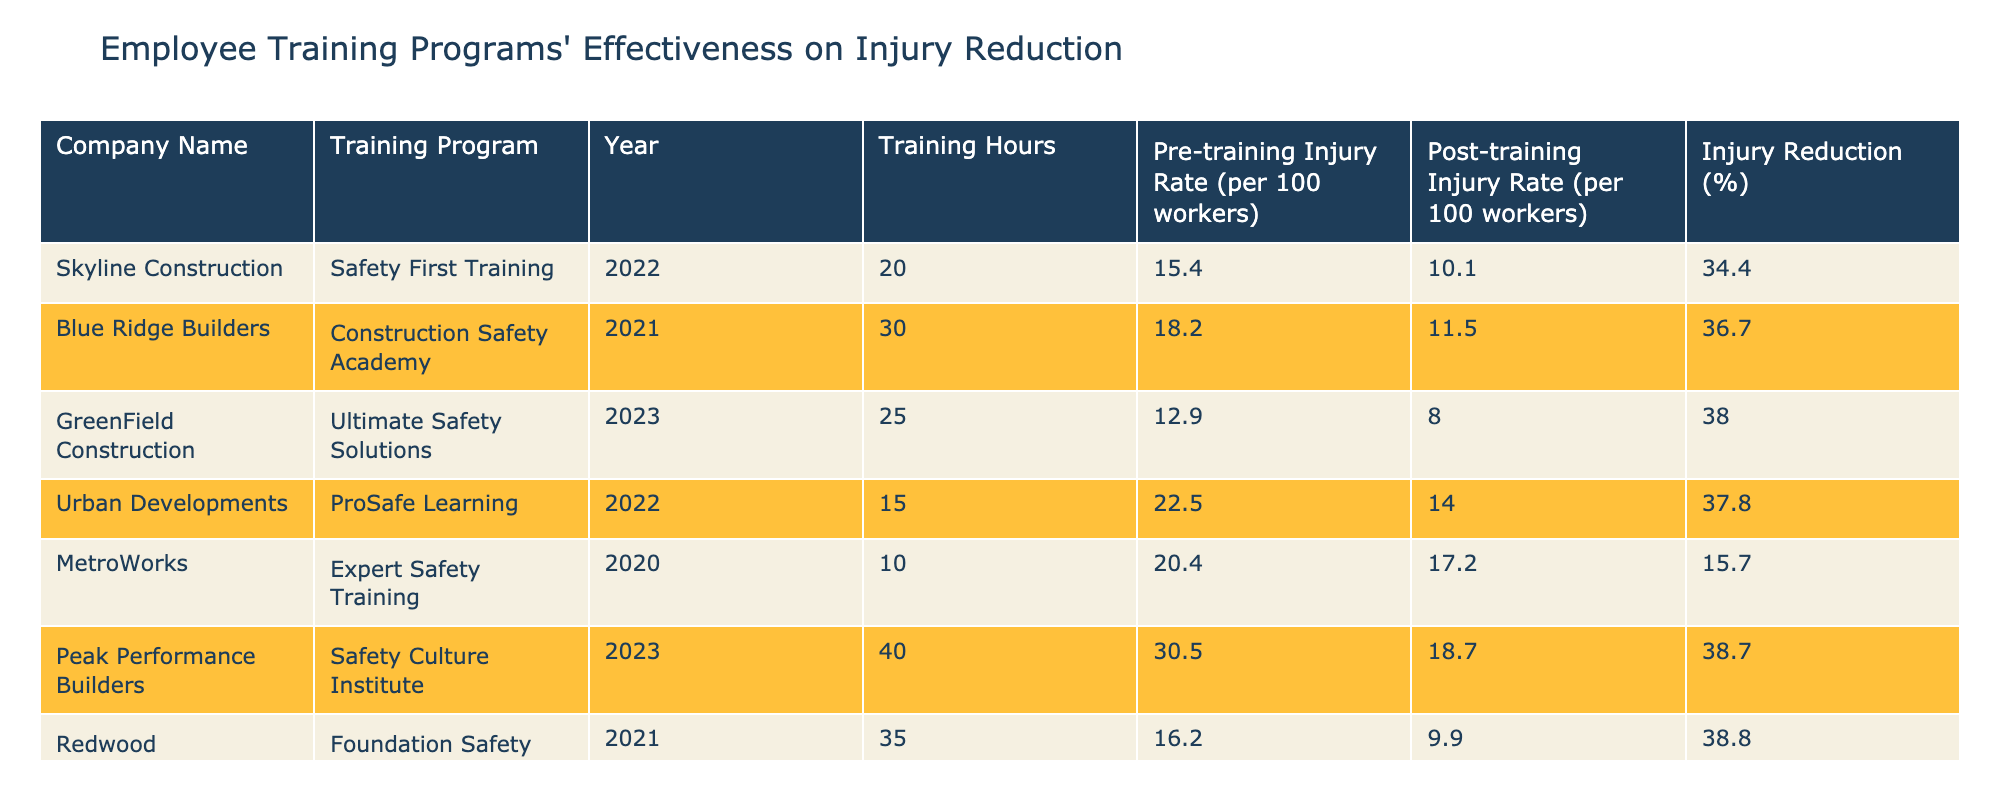What is the training program with the highest injury reduction percentage? The table shows various training programs along with their corresponding injury reduction percentages. Scanning through the injury reduction column, "Foundation Safety Institute" has the highest percentage at 38.8%.
Answer: Foundation Safety Institute Which company implemented the "Ultimate Safety Solutions" training program? The training program "Ultimate Safety Solutions" is listed under "GreenField Construction" in the table.
Answer: GreenField Construction What is the average post-training injury rate across all companies? To find the average post-training injury rate, add the post-training injury rates: (10.1 + 11.5 + 8.0 + 14.0 + 17.2 + 18.7 + 9.9) = 89.4. There are 7 entries, so the average is 89.4 / 7 ≈ 12.77.
Answer: 12.77 Did any of the training programs result in an injury reduction of over 35%? Checking each injury reduction percentage, both "Safety First Training" (34.4%) and "Ultimate Safety Solutions" (38.0%) exceed 35%.
Answer: Yes Which training program required the least amount of training hours? By examining the training hours column, “Expert Safety Training” required the least amount of hours, which is 10.
Answer: Expert Safety Training What is the difference between the highest and lowest pre-training injury rates? The highest pre-training injury rate is 30.5 for "Safety Culture Institute" and the lowest is 12.9 for "Ultimate Safety Solutions." The difference is 30.5 - 12.9 = 17.6.
Answer: 17.6 How many training programs had a post-training injury rate lower than 15? The post-training injury rates lower than 15 are 10.1, 11.5, 8.0, and 14.0. There are 4 such training programs.
Answer: 4 Is it true that all training programs were conducted in the years 2020 to 2023? The table shows programs from the years 2020, 2021, 2022, and 2023, confirming that there are no entries outside this range.
Answer: Yes What company achieved the largest reduction in injuries? By looking through the injury reduction percentages, "Foundation Safety Institute" achieves the largest reduction with 38.8%.
Answer: Foundation Safety Institute 